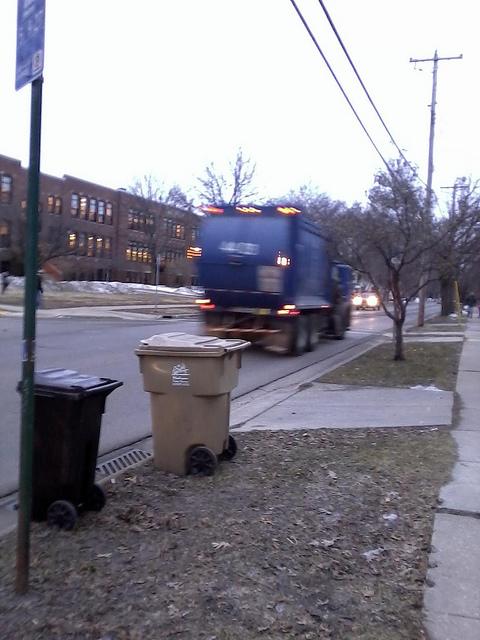What color is the sign?
Answer briefly. Blue. Are there bricks around the tree?
Short answer required. No. What is the difference between the two waste bins?
Short answer required. Color. What is the blue trucks job?
Short answer required. Trash. 